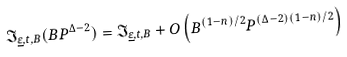Convert formula to latex. <formula><loc_0><loc_0><loc_500><loc_500>\mathfrak { I } _ { \underline { \varepsilon } , t , B } ( B P ^ { \Delta - 2 } ) = \mathfrak { I } _ { \underline { \varepsilon } , t , B } + O \left ( B ^ { ( 1 - n ) / 2 } P ^ { ( \Delta - 2 ) ( 1 - n ) / 2 } \right )</formula> 